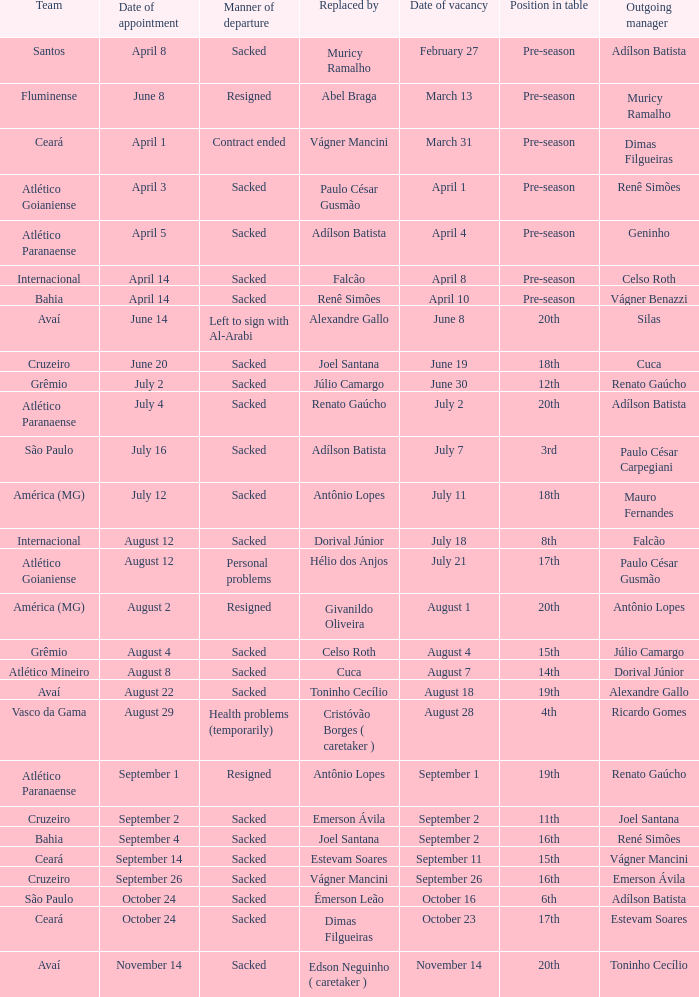How many times did Silas leave as a team manager? 1.0. 